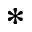<formula> <loc_0><loc_0><loc_500><loc_500>^ { \ast }</formula> 